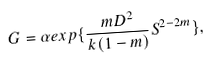Convert formula to latex. <formula><loc_0><loc_0><loc_500><loc_500>G = \alpha e x p \{ { \frac { m D ^ { 2 } } { k ( 1 - m ) } S ^ { 2 - 2 m } } \} ,</formula> 